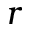<formula> <loc_0><loc_0><loc_500><loc_500>r</formula> 